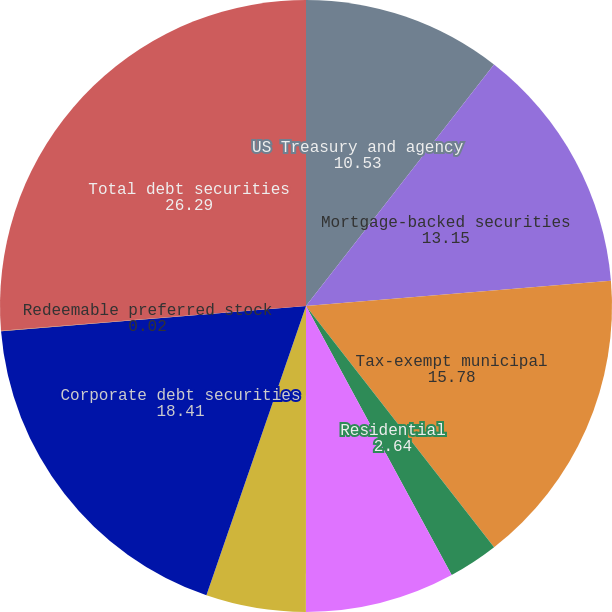Convert chart to OTSL. <chart><loc_0><loc_0><loc_500><loc_500><pie_chart><fcel>US Treasury and agency<fcel>Mortgage-backed securities<fcel>Tax-exempt municipal<fcel>Residential<fcel>Commercial<fcel>Asset-backed securities<fcel>Corporate debt securities<fcel>Redeemable preferred stock<fcel>Total debt securities<nl><fcel>10.53%<fcel>13.15%<fcel>15.78%<fcel>2.64%<fcel>7.9%<fcel>5.27%<fcel>18.41%<fcel>0.02%<fcel>26.29%<nl></chart> 